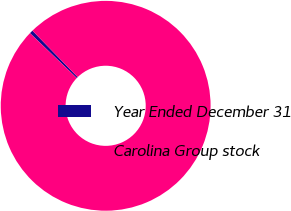<chart> <loc_0><loc_0><loc_500><loc_500><pie_chart><fcel>Year Ended December 31<fcel>Carolina Group stock<nl><fcel>0.53%<fcel>99.47%<nl></chart> 